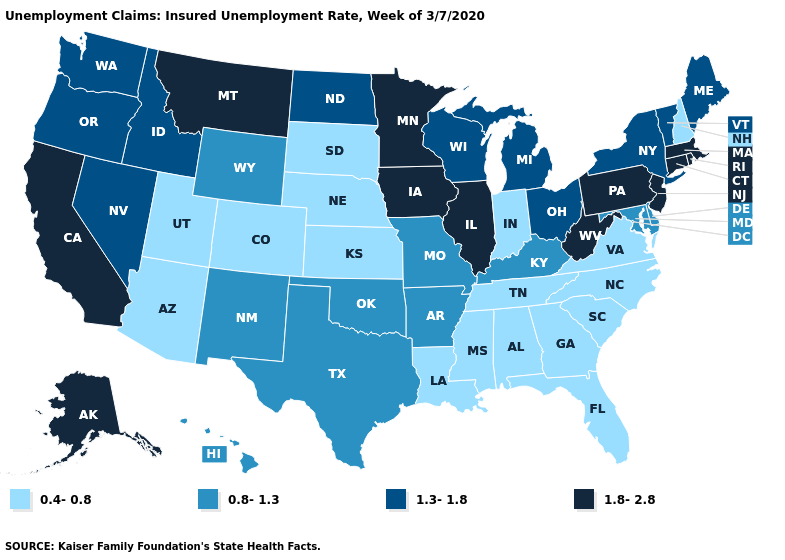What is the lowest value in the MidWest?
Give a very brief answer. 0.4-0.8. Name the states that have a value in the range 0.8-1.3?
Keep it brief. Arkansas, Delaware, Hawaii, Kentucky, Maryland, Missouri, New Mexico, Oklahoma, Texas, Wyoming. Among the states that border Wisconsin , does Michigan have the highest value?
Be succinct. No. What is the value of North Dakota?
Concise answer only. 1.3-1.8. Does the map have missing data?
Concise answer only. No. Does Pennsylvania have the highest value in the USA?
Quick response, please. Yes. Does Minnesota have a higher value than Oregon?
Give a very brief answer. Yes. What is the value of Washington?
Be succinct. 1.3-1.8. What is the value of Mississippi?
Answer briefly. 0.4-0.8. Does New York have the lowest value in the Northeast?
Be succinct. No. What is the value of West Virginia?
Short answer required. 1.8-2.8. Does North Dakota have a higher value than Maryland?
Short answer required. Yes. What is the highest value in the USA?
Concise answer only. 1.8-2.8. What is the value of Arizona?
Quick response, please. 0.4-0.8. Does Massachusetts have the same value as South Carolina?
Write a very short answer. No. 